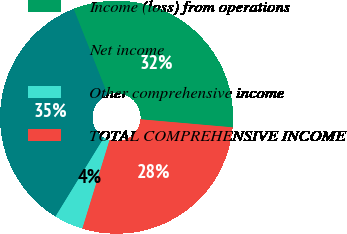Convert chart. <chart><loc_0><loc_0><loc_500><loc_500><pie_chart><fcel>Income (loss) from operations<fcel>Net income<fcel>Other comprehensive income<fcel>TOTAL COMPREHENSIVE INCOME<nl><fcel>32.39%<fcel>35.22%<fcel>4.03%<fcel>28.35%<nl></chart> 